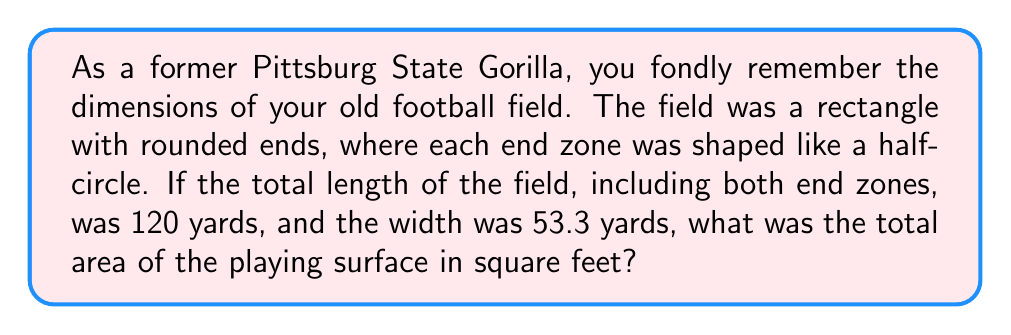Can you answer this question? Let's approach this step-by-step:

1) First, we need to convert yards to feet:
   120 yards = 120 * 3 = 360 feet (length)
   53.3 yards = 53.3 * 3 = 159.9 feet (width)

2) The field consists of a rectangle in the middle and two half-circles at the ends.

3) Let's calculate the radius of the half-circles:
   Each end zone is 10 yards (30 feet) deep.
   So, the radius of each half-circle is 30 feet.

4) The length of the rectangular part:
   $$ L_{rect} = 360 - (2 * 30) = 300 \text{ feet} $$

5) Area of the rectangle:
   $$ A_{rect} = 300 * 159.9 = 47,970 \text{ sq ft} $$

6) Area of one half-circle:
   $$ A_{half-circle} = \frac{1}{2} \pi r^2 = \frac{1}{2} \pi (30)^2 = 1,413.72 \text{ sq ft} $$

7) Total area of both half-circles:
   $$ A_{circles} = 2 * 1,413.72 = 2,827.44 \text{ sq ft} $$

8) Total area of the field:
   $$ A_{total} = A_{rect} + A_{circles} = 47,970 + 2,827.44 = 50,797.44 \text{ sq ft} $$

[asy]
unitsize(0.02inch);
fill((0,0)--(360,0)--(360,159.9)--(0,159.9)--cycle,rgb(0.2,0.8,0.2));
fill(arc((30,79.95),30,90,270),rgb(0.2,0.8,0.2));
fill(arc((330,79.95),30,-90,90),rgb(0.2,0.8,0.2));
draw((0,0)--(360,0)--(360,159.9)--(0,159.9)--cycle);
draw((30,0)--(30,159.9));
draw((330,0)--(330,159.9));
label("360 ft", (180,-10), S);
label("159.9 ft", (370,79.95), E);
label("30 ft", (15,79.95), W);
label("300 ft", (180,170), N);
[/asy]
Answer: 50,797.44 sq ft 